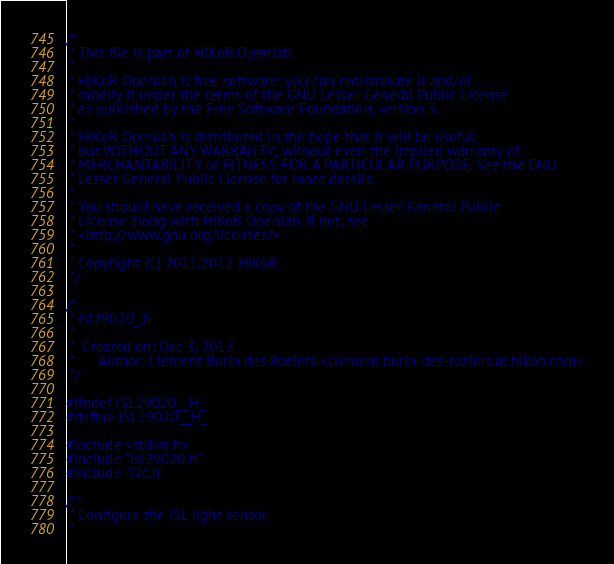<code> <loc_0><loc_0><loc_500><loc_500><_C_>/*
 * This file is part of HiKoB Openlab.
 *
 * HiKoB Openlab is free software: you can redistribute it and/or
 * modify it under the terms of the GNU Lesser General Public License
 * as published by the Free Software Foundation, version 3.
 *
 * HiKoB Openlab is distributed in the hope that it will be useful,
 * but WITHOUT ANY WARRANTY; without even the implied warranty of
 * MERCHANTABILITY or FITNESS FOR A PARTICULAR PURPOSE. See the GNU
 * Lesser General Public License for more details.
 *
 * You should have received a copy of the GNU Lesser General Public
 * License along with HiKoB Openlab. If not, see
 * <http://www.gnu.org/licenses/>.
 *
 * Copyright (C) 2011,2012 HiKoB.
 */

/*
 * isl29020_.h
 *
 *  Created on: Dec 3, 2012
 *      Author: Clément Burin des Roziers <clement.burin-des-roziers.at.hikob.com>
 */

#ifndef ISL29020__H_
#define ISL29020__H_

#include <stdint.h>
#include "isl29020.h"
#include "i2c.h"

/**
 * Configure the ISL light sensor.
 *</code> 